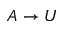<formula> <loc_0><loc_0><loc_500><loc_500>A \to U</formula> 